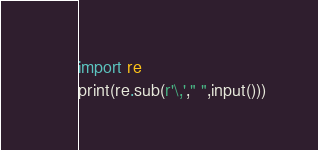Convert code to text. <code><loc_0><loc_0><loc_500><loc_500><_Python_>import re
print(re.sub(r'\,'," ",input()))</code> 